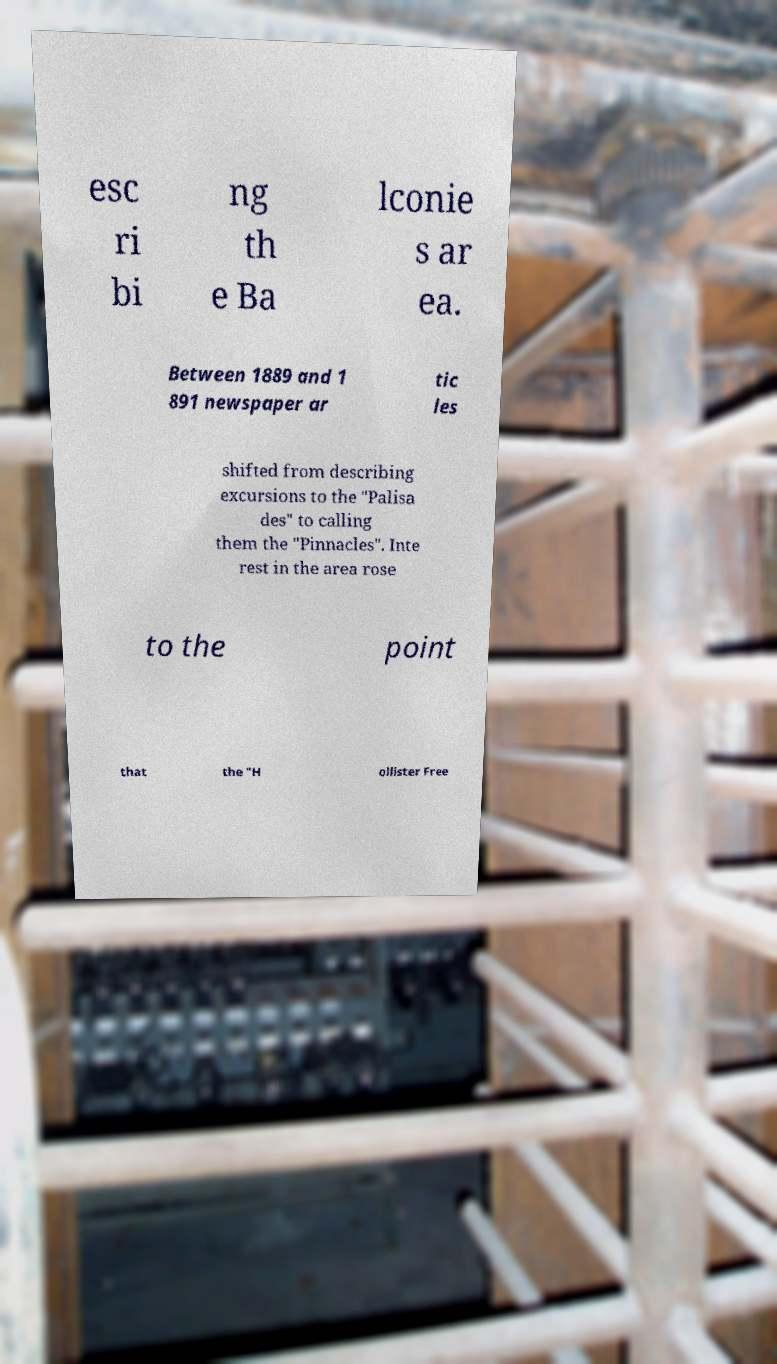Please read and relay the text visible in this image. What does it say? esc ri bi ng th e Ba lconie s ar ea. Between 1889 and 1 891 newspaper ar tic les shifted from describing excursions to the "Palisa des" to calling them the "Pinnacles". Inte rest in the area rose to the point that the "H ollister Free 